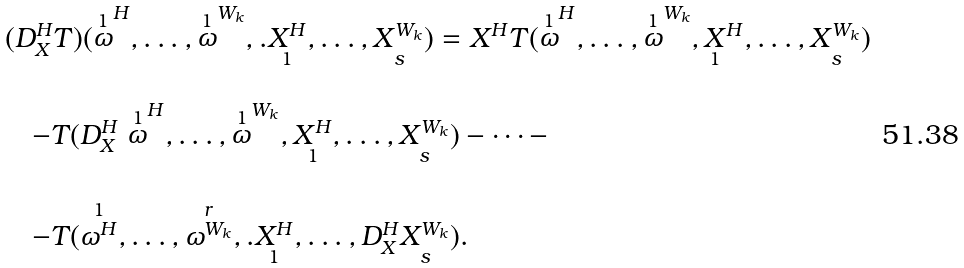<formula> <loc_0><loc_0><loc_500><loc_500>\begin{array} { l } ( D _ { X } ^ { H } T ) ( \stackrel { 1 } { \omega } ^ { H } , \dots , \stackrel { 1 } { \omega } ^ { W _ { k } } , . \underset { 1 } { X ^ { H } } , \dots , \underset { s } { X ^ { W _ { k } } } ) = X ^ { H } T ( \stackrel { 1 } { \omega } ^ { H } , \dots , \stackrel { 1 } { \omega } ^ { W _ { k } } , \underset { 1 } { X } ^ { H } , \dots , \underset { s } { X ^ { W _ { k } } } ) \\ \\ \quad - T ( D _ { X } ^ { H } \stackrel { 1 } { \omega } ^ { H } , \dots , \stackrel { 1 } { \omega } ^ { W _ { k } } , \underset { 1 } { X ^ { H } } , \dots , \underset { s } { X ^ { W _ { k } } } ) - \dots - \\ \\ \quad - T ( \stackrel { 1 } { \omega ^ { H } } , \dots , \stackrel { r } { \omega ^ { W _ { k } } } , . \underset { 1 } { X ^ { H } } , \dots , D _ { X } ^ { H } \underset { s } { X ^ { W _ { k } } } ) . \end{array}</formula> 